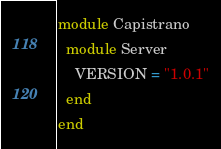<code> <loc_0><loc_0><loc_500><loc_500><_Ruby_>module Capistrano
  module Server
    VERSION = "1.0.1"
  end
end
</code> 